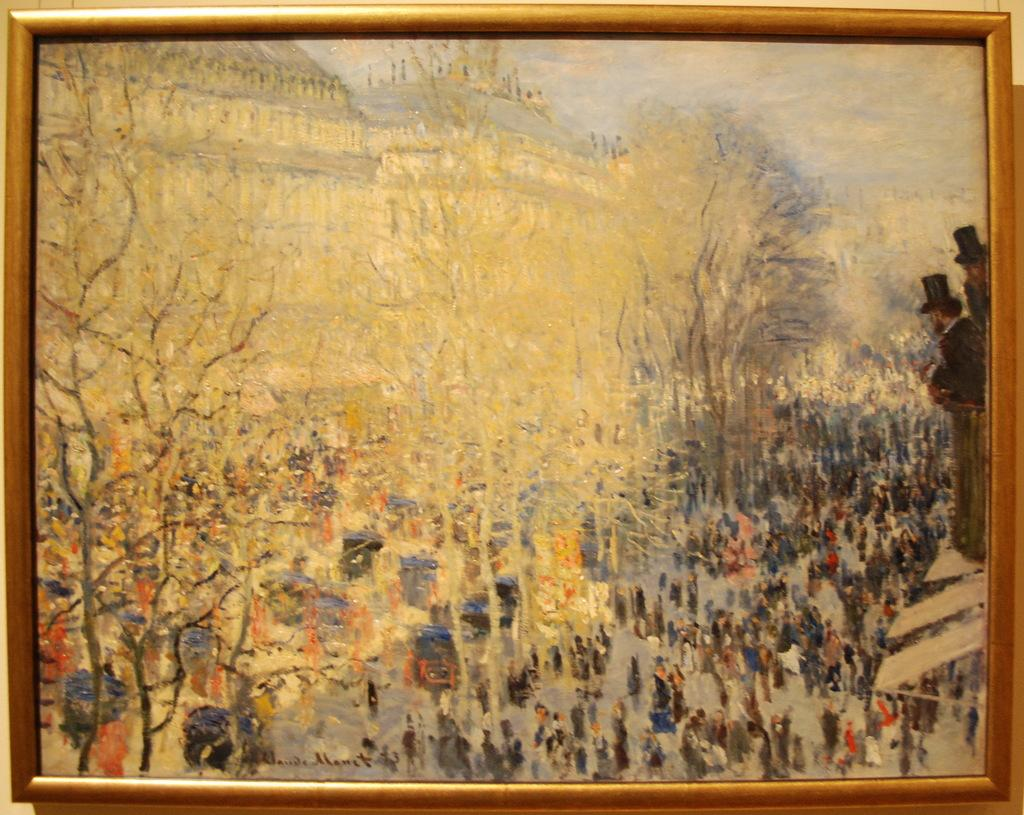What object in the image contains a painting? There is a photo frame in the image that contains a painting. What is the subject of the painting? The painting depicts people gathered on the road. What can be seen in the background of the image? There are trees and buildings visible in the image. What is the cause of the people jumping in the image? There are no people jumping in the image; the painting depicts people gathered on the road, not jumping. What is the base of the photo frame in the image? The provided facts do not mention the base of the photo frame, so we cannot definitively answer this question. 